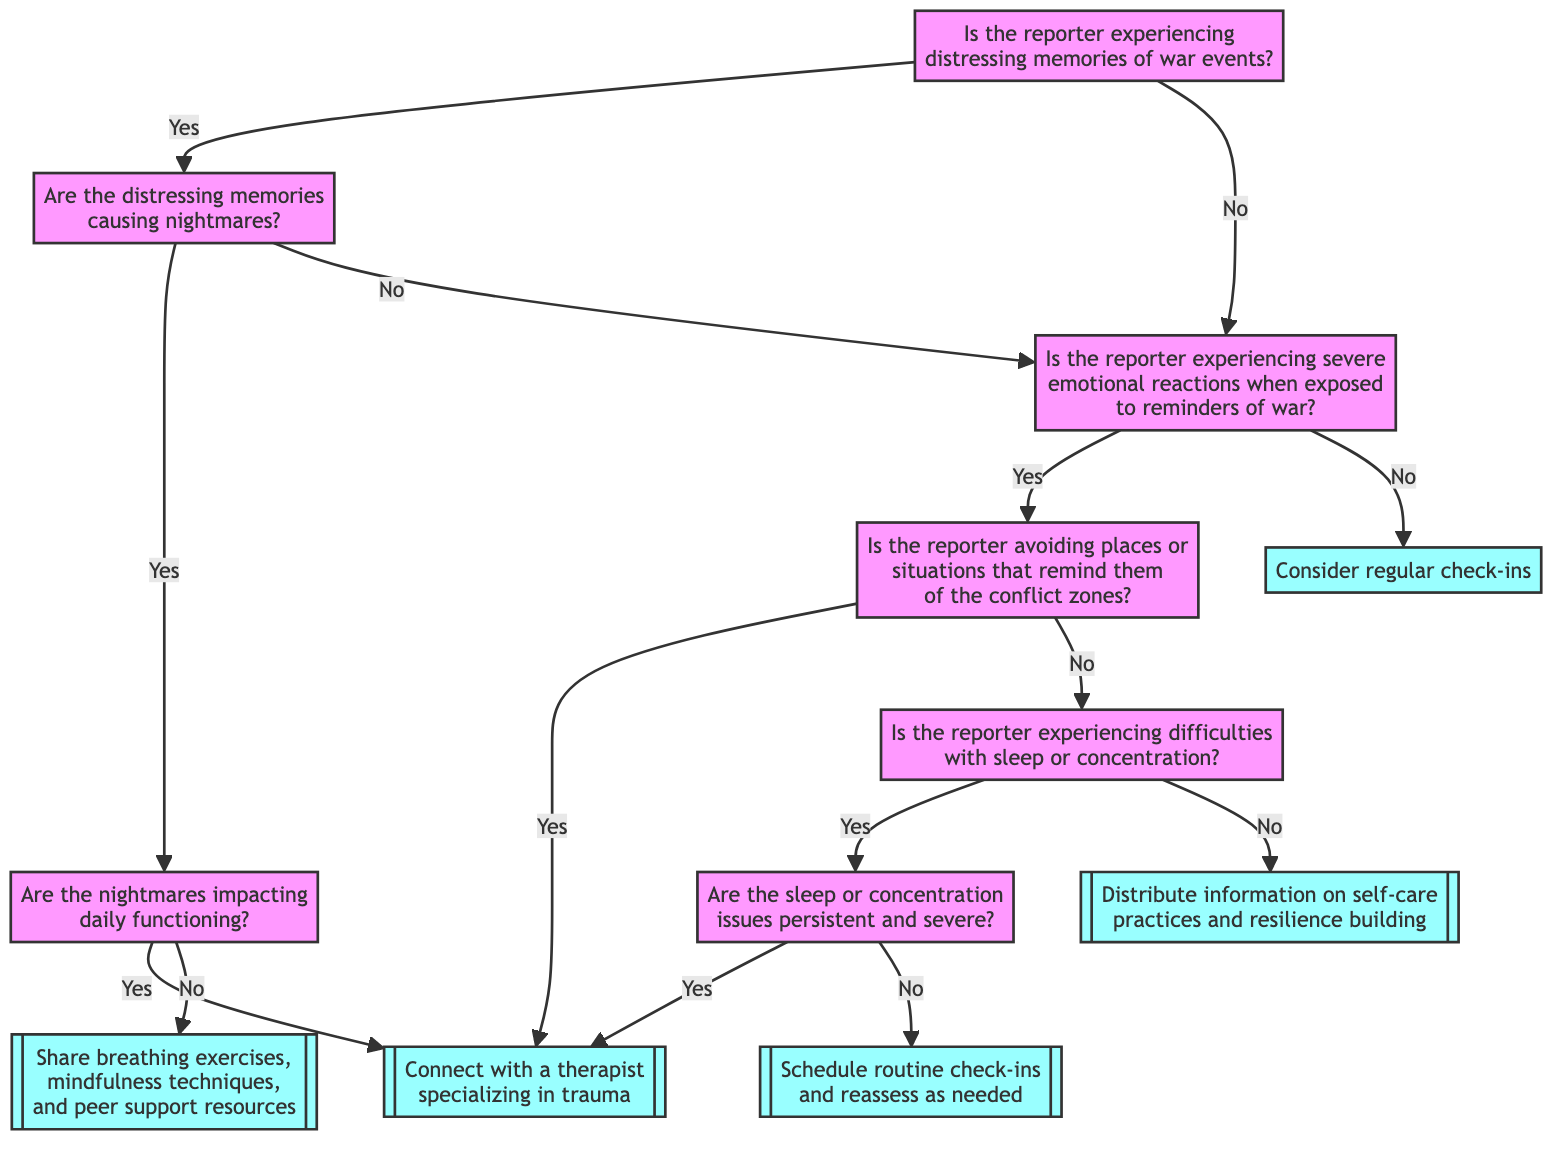What is the first question asked in the flowchart? The flowchart starts by asking if the reporter is experiencing distressing memories of war events. This is represented by the first node labeled "Is the reporter experiencing distressing memories of war events?"
Answer: Is the reporter experiencing distressing memories of war events? How many actions are suggested in the flowchart? The flowchart suggests four different actions which are: Recommend professional counseling, Provide coping strategies, Provide self-help resources, and Monitor progress. Each action is linked to a specific condition evaluated within the flowchart.
Answer: Four What happens if the reporter is not experiencing severe emotional reactions? If the reporter is not experiencing severe emotional reactions when exposed to reminders of war, the flowchart suggests considering regular check-ins as the next step. This decision is derived from the question about emotional reactions.
Answer: Consider regular check-ins What are the two possible pathways after the reporter evaluates nightmares? After the reporter evaluates nightmares, the two pathways are: if the nightmares impact daily functioning, the action is to recommend professional counseling; if they do not impact daily functioning, the action is to consider coping strategies.
Answer: Recommend professional counseling or consider coping strategies If the reporter is avoiding reminders of war, what is the recommended action? If the reporter is avoiding places or situations that remind them of the conflict zones, the recommended action is to recommend professional counseling, indicating a need for specialized support.
Answer: Recommend professional counseling What does the flowchart provide if the reporter is experiencing difficulties with sleep or concentration but they are not persistent and severe? If the reporter is experiencing difficulties with sleep or concentration that are not persistent and severe, the flowchart indicates that self-help resources should be provided. This is a supportive measure to assist the reporter's coping strategies.
Answer: Provide self-help resources What is the final output from the flowchart if the reporter's concentration issues are persistent and severe? If the reporter's sleep or concentration issues are persistent and severe, the flowchart outlines that the next step is to recommend professional counseling, as it highlights the need for professional intervention for severe issues.
Answer: Recommend professional counseling Where does the diagram go after evaluating the impact of nightmares on daily functioning? After evaluating the impact of nightmares on daily functioning, if they do impact functioning, the flowchart leads to recommending professional counseling; if they do not, it leads to considering coping strategies.
Answer: Recommend professional counseling or consider coping strategies 